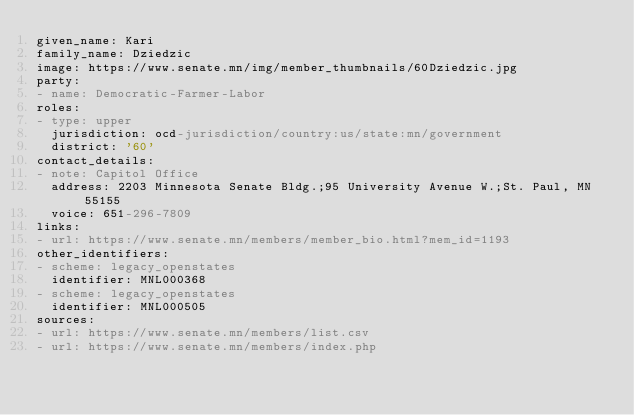<code> <loc_0><loc_0><loc_500><loc_500><_YAML_>given_name: Kari
family_name: Dziedzic
image: https://www.senate.mn/img/member_thumbnails/60Dziedzic.jpg
party:
- name: Democratic-Farmer-Labor
roles:
- type: upper
  jurisdiction: ocd-jurisdiction/country:us/state:mn/government
  district: '60'
contact_details:
- note: Capitol Office
  address: 2203 Minnesota Senate Bldg.;95 University Avenue W.;St. Paul, MN 55155
  voice: 651-296-7809
links:
- url: https://www.senate.mn/members/member_bio.html?mem_id=1193
other_identifiers:
- scheme: legacy_openstates
  identifier: MNL000368
- scheme: legacy_openstates
  identifier: MNL000505
sources:
- url: https://www.senate.mn/members/list.csv
- url: https://www.senate.mn/members/index.php
</code> 